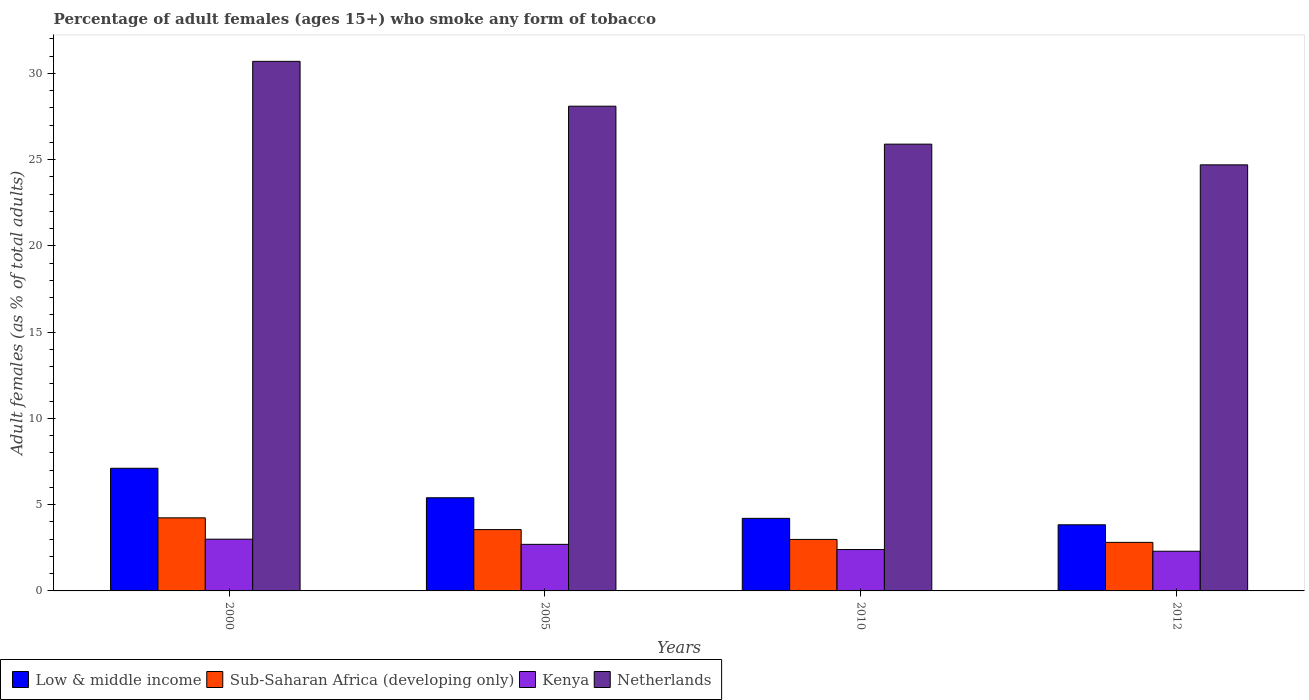How many different coloured bars are there?
Provide a succinct answer. 4. How many bars are there on the 3rd tick from the left?
Ensure brevity in your answer.  4. How many bars are there on the 3rd tick from the right?
Your answer should be compact. 4. What is the label of the 1st group of bars from the left?
Your answer should be very brief. 2000. Across all years, what is the minimum percentage of adult females who smoke in Netherlands?
Provide a succinct answer. 24.7. In which year was the percentage of adult females who smoke in Sub-Saharan Africa (developing only) maximum?
Offer a terse response. 2000. What is the total percentage of adult females who smoke in Kenya in the graph?
Your response must be concise. 10.4. What is the difference between the percentage of adult females who smoke in Sub-Saharan Africa (developing only) in 2000 and that in 2010?
Keep it short and to the point. 1.25. What is the difference between the percentage of adult females who smoke in Kenya in 2000 and the percentage of adult females who smoke in Netherlands in 2010?
Ensure brevity in your answer.  -22.9. What is the average percentage of adult females who smoke in Sub-Saharan Africa (developing only) per year?
Offer a terse response. 3.4. In the year 2000, what is the difference between the percentage of adult females who smoke in Kenya and percentage of adult females who smoke in Sub-Saharan Africa (developing only)?
Make the answer very short. -1.24. In how many years, is the percentage of adult females who smoke in Netherlands greater than 5 %?
Offer a very short reply. 4. What is the ratio of the percentage of adult females who smoke in Kenya in 2000 to that in 2010?
Make the answer very short. 1.25. What is the difference between the highest and the second highest percentage of adult females who smoke in Sub-Saharan Africa (developing only)?
Offer a terse response. 0.68. What is the difference between the highest and the lowest percentage of adult females who smoke in Sub-Saharan Africa (developing only)?
Your answer should be very brief. 1.42. In how many years, is the percentage of adult females who smoke in Low & middle income greater than the average percentage of adult females who smoke in Low & middle income taken over all years?
Offer a very short reply. 2. Are all the bars in the graph horizontal?
Ensure brevity in your answer.  No. Does the graph contain grids?
Provide a succinct answer. No. Where does the legend appear in the graph?
Give a very brief answer. Bottom left. How many legend labels are there?
Provide a short and direct response. 4. What is the title of the graph?
Make the answer very short. Percentage of adult females (ages 15+) who smoke any form of tobacco. Does "Latin America(developing only)" appear as one of the legend labels in the graph?
Your answer should be compact. No. What is the label or title of the Y-axis?
Keep it short and to the point. Adult females (as % of total adults). What is the Adult females (as % of total adults) in Low & middle income in 2000?
Offer a very short reply. 7.11. What is the Adult females (as % of total adults) in Sub-Saharan Africa (developing only) in 2000?
Your answer should be compact. 4.24. What is the Adult females (as % of total adults) in Netherlands in 2000?
Offer a terse response. 30.7. What is the Adult females (as % of total adults) in Low & middle income in 2005?
Ensure brevity in your answer.  5.4. What is the Adult females (as % of total adults) of Sub-Saharan Africa (developing only) in 2005?
Give a very brief answer. 3.55. What is the Adult females (as % of total adults) of Netherlands in 2005?
Your answer should be compact. 28.1. What is the Adult females (as % of total adults) of Low & middle income in 2010?
Offer a terse response. 4.21. What is the Adult females (as % of total adults) of Sub-Saharan Africa (developing only) in 2010?
Offer a very short reply. 2.99. What is the Adult females (as % of total adults) of Kenya in 2010?
Provide a short and direct response. 2.4. What is the Adult females (as % of total adults) in Netherlands in 2010?
Offer a very short reply. 25.9. What is the Adult females (as % of total adults) in Low & middle income in 2012?
Your response must be concise. 3.83. What is the Adult females (as % of total adults) in Sub-Saharan Africa (developing only) in 2012?
Ensure brevity in your answer.  2.81. What is the Adult females (as % of total adults) of Kenya in 2012?
Your response must be concise. 2.3. What is the Adult females (as % of total adults) of Netherlands in 2012?
Make the answer very short. 24.7. Across all years, what is the maximum Adult females (as % of total adults) of Low & middle income?
Offer a terse response. 7.11. Across all years, what is the maximum Adult females (as % of total adults) in Sub-Saharan Africa (developing only)?
Keep it short and to the point. 4.24. Across all years, what is the maximum Adult females (as % of total adults) in Kenya?
Your response must be concise. 3. Across all years, what is the maximum Adult females (as % of total adults) in Netherlands?
Your response must be concise. 30.7. Across all years, what is the minimum Adult females (as % of total adults) in Low & middle income?
Provide a succinct answer. 3.83. Across all years, what is the minimum Adult females (as % of total adults) of Sub-Saharan Africa (developing only)?
Keep it short and to the point. 2.81. Across all years, what is the minimum Adult females (as % of total adults) of Netherlands?
Offer a very short reply. 24.7. What is the total Adult females (as % of total adults) of Low & middle income in the graph?
Provide a short and direct response. 20.55. What is the total Adult females (as % of total adults) in Sub-Saharan Africa (developing only) in the graph?
Your answer should be very brief. 13.59. What is the total Adult females (as % of total adults) in Netherlands in the graph?
Make the answer very short. 109.4. What is the difference between the Adult females (as % of total adults) in Low & middle income in 2000 and that in 2005?
Your answer should be very brief. 1.71. What is the difference between the Adult females (as % of total adults) in Sub-Saharan Africa (developing only) in 2000 and that in 2005?
Your answer should be compact. 0.68. What is the difference between the Adult females (as % of total adults) of Low & middle income in 2000 and that in 2010?
Make the answer very short. 2.9. What is the difference between the Adult females (as % of total adults) of Sub-Saharan Africa (developing only) in 2000 and that in 2010?
Keep it short and to the point. 1.25. What is the difference between the Adult females (as % of total adults) of Kenya in 2000 and that in 2010?
Offer a terse response. 0.6. What is the difference between the Adult females (as % of total adults) of Netherlands in 2000 and that in 2010?
Offer a very short reply. 4.8. What is the difference between the Adult females (as % of total adults) in Low & middle income in 2000 and that in 2012?
Keep it short and to the point. 3.28. What is the difference between the Adult females (as % of total adults) of Sub-Saharan Africa (developing only) in 2000 and that in 2012?
Offer a terse response. 1.42. What is the difference between the Adult females (as % of total adults) in Low & middle income in 2005 and that in 2010?
Offer a terse response. 1.19. What is the difference between the Adult females (as % of total adults) of Sub-Saharan Africa (developing only) in 2005 and that in 2010?
Offer a very short reply. 0.57. What is the difference between the Adult females (as % of total adults) of Netherlands in 2005 and that in 2010?
Offer a terse response. 2.2. What is the difference between the Adult females (as % of total adults) in Low & middle income in 2005 and that in 2012?
Your answer should be very brief. 1.57. What is the difference between the Adult females (as % of total adults) in Sub-Saharan Africa (developing only) in 2005 and that in 2012?
Make the answer very short. 0.74. What is the difference between the Adult females (as % of total adults) of Netherlands in 2005 and that in 2012?
Your answer should be compact. 3.4. What is the difference between the Adult females (as % of total adults) of Low & middle income in 2010 and that in 2012?
Offer a very short reply. 0.37. What is the difference between the Adult females (as % of total adults) of Sub-Saharan Africa (developing only) in 2010 and that in 2012?
Ensure brevity in your answer.  0.17. What is the difference between the Adult females (as % of total adults) of Kenya in 2010 and that in 2012?
Give a very brief answer. 0.1. What is the difference between the Adult females (as % of total adults) of Netherlands in 2010 and that in 2012?
Offer a very short reply. 1.2. What is the difference between the Adult females (as % of total adults) of Low & middle income in 2000 and the Adult females (as % of total adults) of Sub-Saharan Africa (developing only) in 2005?
Your answer should be very brief. 3.56. What is the difference between the Adult females (as % of total adults) of Low & middle income in 2000 and the Adult females (as % of total adults) of Kenya in 2005?
Your answer should be very brief. 4.41. What is the difference between the Adult females (as % of total adults) of Low & middle income in 2000 and the Adult females (as % of total adults) of Netherlands in 2005?
Offer a very short reply. -20.99. What is the difference between the Adult females (as % of total adults) of Sub-Saharan Africa (developing only) in 2000 and the Adult females (as % of total adults) of Kenya in 2005?
Your answer should be very brief. 1.54. What is the difference between the Adult females (as % of total adults) of Sub-Saharan Africa (developing only) in 2000 and the Adult females (as % of total adults) of Netherlands in 2005?
Offer a very short reply. -23.86. What is the difference between the Adult females (as % of total adults) of Kenya in 2000 and the Adult females (as % of total adults) of Netherlands in 2005?
Your answer should be very brief. -25.1. What is the difference between the Adult females (as % of total adults) in Low & middle income in 2000 and the Adult females (as % of total adults) in Sub-Saharan Africa (developing only) in 2010?
Make the answer very short. 4.13. What is the difference between the Adult females (as % of total adults) in Low & middle income in 2000 and the Adult females (as % of total adults) in Kenya in 2010?
Offer a terse response. 4.71. What is the difference between the Adult females (as % of total adults) in Low & middle income in 2000 and the Adult females (as % of total adults) in Netherlands in 2010?
Your response must be concise. -18.79. What is the difference between the Adult females (as % of total adults) of Sub-Saharan Africa (developing only) in 2000 and the Adult females (as % of total adults) of Kenya in 2010?
Offer a terse response. 1.84. What is the difference between the Adult females (as % of total adults) in Sub-Saharan Africa (developing only) in 2000 and the Adult females (as % of total adults) in Netherlands in 2010?
Your answer should be very brief. -21.66. What is the difference between the Adult females (as % of total adults) of Kenya in 2000 and the Adult females (as % of total adults) of Netherlands in 2010?
Make the answer very short. -22.9. What is the difference between the Adult females (as % of total adults) in Low & middle income in 2000 and the Adult females (as % of total adults) in Sub-Saharan Africa (developing only) in 2012?
Offer a very short reply. 4.3. What is the difference between the Adult females (as % of total adults) of Low & middle income in 2000 and the Adult females (as % of total adults) of Kenya in 2012?
Offer a very short reply. 4.81. What is the difference between the Adult females (as % of total adults) of Low & middle income in 2000 and the Adult females (as % of total adults) of Netherlands in 2012?
Your response must be concise. -17.59. What is the difference between the Adult females (as % of total adults) of Sub-Saharan Africa (developing only) in 2000 and the Adult females (as % of total adults) of Kenya in 2012?
Make the answer very short. 1.94. What is the difference between the Adult females (as % of total adults) in Sub-Saharan Africa (developing only) in 2000 and the Adult females (as % of total adults) in Netherlands in 2012?
Give a very brief answer. -20.46. What is the difference between the Adult females (as % of total adults) in Kenya in 2000 and the Adult females (as % of total adults) in Netherlands in 2012?
Offer a terse response. -21.7. What is the difference between the Adult females (as % of total adults) of Low & middle income in 2005 and the Adult females (as % of total adults) of Sub-Saharan Africa (developing only) in 2010?
Provide a succinct answer. 2.42. What is the difference between the Adult females (as % of total adults) in Low & middle income in 2005 and the Adult females (as % of total adults) in Kenya in 2010?
Offer a very short reply. 3. What is the difference between the Adult females (as % of total adults) in Low & middle income in 2005 and the Adult females (as % of total adults) in Netherlands in 2010?
Your answer should be compact. -20.5. What is the difference between the Adult females (as % of total adults) in Sub-Saharan Africa (developing only) in 2005 and the Adult females (as % of total adults) in Kenya in 2010?
Ensure brevity in your answer.  1.15. What is the difference between the Adult females (as % of total adults) in Sub-Saharan Africa (developing only) in 2005 and the Adult females (as % of total adults) in Netherlands in 2010?
Offer a very short reply. -22.35. What is the difference between the Adult females (as % of total adults) of Kenya in 2005 and the Adult females (as % of total adults) of Netherlands in 2010?
Your answer should be very brief. -23.2. What is the difference between the Adult females (as % of total adults) of Low & middle income in 2005 and the Adult females (as % of total adults) of Sub-Saharan Africa (developing only) in 2012?
Offer a very short reply. 2.59. What is the difference between the Adult females (as % of total adults) of Low & middle income in 2005 and the Adult females (as % of total adults) of Kenya in 2012?
Give a very brief answer. 3.1. What is the difference between the Adult females (as % of total adults) in Low & middle income in 2005 and the Adult females (as % of total adults) in Netherlands in 2012?
Ensure brevity in your answer.  -19.3. What is the difference between the Adult females (as % of total adults) of Sub-Saharan Africa (developing only) in 2005 and the Adult females (as % of total adults) of Kenya in 2012?
Make the answer very short. 1.25. What is the difference between the Adult females (as % of total adults) in Sub-Saharan Africa (developing only) in 2005 and the Adult females (as % of total adults) in Netherlands in 2012?
Keep it short and to the point. -21.15. What is the difference between the Adult females (as % of total adults) of Kenya in 2005 and the Adult females (as % of total adults) of Netherlands in 2012?
Provide a short and direct response. -22. What is the difference between the Adult females (as % of total adults) of Low & middle income in 2010 and the Adult females (as % of total adults) of Sub-Saharan Africa (developing only) in 2012?
Keep it short and to the point. 1.39. What is the difference between the Adult females (as % of total adults) in Low & middle income in 2010 and the Adult females (as % of total adults) in Kenya in 2012?
Offer a very short reply. 1.91. What is the difference between the Adult females (as % of total adults) in Low & middle income in 2010 and the Adult females (as % of total adults) in Netherlands in 2012?
Offer a very short reply. -20.49. What is the difference between the Adult females (as % of total adults) in Sub-Saharan Africa (developing only) in 2010 and the Adult females (as % of total adults) in Kenya in 2012?
Offer a very short reply. 0.69. What is the difference between the Adult females (as % of total adults) in Sub-Saharan Africa (developing only) in 2010 and the Adult females (as % of total adults) in Netherlands in 2012?
Provide a succinct answer. -21.71. What is the difference between the Adult females (as % of total adults) in Kenya in 2010 and the Adult females (as % of total adults) in Netherlands in 2012?
Offer a very short reply. -22.3. What is the average Adult females (as % of total adults) in Low & middle income per year?
Your answer should be compact. 5.14. What is the average Adult females (as % of total adults) in Sub-Saharan Africa (developing only) per year?
Provide a short and direct response. 3.4. What is the average Adult females (as % of total adults) in Kenya per year?
Keep it short and to the point. 2.6. What is the average Adult females (as % of total adults) in Netherlands per year?
Keep it short and to the point. 27.35. In the year 2000, what is the difference between the Adult females (as % of total adults) of Low & middle income and Adult females (as % of total adults) of Sub-Saharan Africa (developing only)?
Keep it short and to the point. 2.87. In the year 2000, what is the difference between the Adult females (as % of total adults) of Low & middle income and Adult females (as % of total adults) of Kenya?
Ensure brevity in your answer.  4.11. In the year 2000, what is the difference between the Adult females (as % of total adults) of Low & middle income and Adult females (as % of total adults) of Netherlands?
Your answer should be compact. -23.59. In the year 2000, what is the difference between the Adult females (as % of total adults) of Sub-Saharan Africa (developing only) and Adult females (as % of total adults) of Kenya?
Make the answer very short. 1.24. In the year 2000, what is the difference between the Adult females (as % of total adults) in Sub-Saharan Africa (developing only) and Adult females (as % of total adults) in Netherlands?
Make the answer very short. -26.46. In the year 2000, what is the difference between the Adult females (as % of total adults) of Kenya and Adult females (as % of total adults) of Netherlands?
Provide a succinct answer. -27.7. In the year 2005, what is the difference between the Adult females (as % of total adults) of Low & middle income and Adult females (as % of total adults) of Sub-Saharan Africa (developing only)?
Offer a terse response. 1.85. In the year 2005, what is the difference between the Adult females (as % of total adults) of Low & middle income and Adult females (as % of total adults) of Kenya?
Ensure brevity in your answer.  2.7. In the year 2005, what is the difference between the Adult females (as % of total adults) in Low & middle income and Adult females (as % of total adults) in Netherlands?
Your answer should be compact. -22.7. In the year 2005, what is the difference between the Adult females (as % of total adults) of Sub-Saharan Africa (developing only) and Adult females (as % of total adults) of Kenya?
Offer a very short reply. 0.85. In the year 2005, what is the difference between the Adult females (as % of total adults) of Sub-Saharan Africa (developing only) and Adult females (as % of total adults) of Netherlands?
Provide a succinct answer. -24.55. In the year 2005, what is the difference between the Adult females (as % of total adults) of Kenya and Adult females (as % of total adults) of Netherlands?
Provide a succinct answer. -25.4. In the year 2010, what is the difference between the Adult females (as % of total adults) in Low & middle income and Adult females (as % of total adults) in Sub-Saharan Africa (developing only)?
Offer a terse response. 1.22. In the year 2010, what is the difference between the Adult females (as % of total adults) of Low & middle income and Adult females (as % of total adults) of Kenya?
Give a very brief answer. 1.81. In the year 2010, what is the difference between the Adult females (as % of total adults) in Low & middle income and Adult females (as % of total adults) in Netherlands?
Provide a succinct answer. -21.69. In the year 2010, what is the difference between the Adult females (as % of total adults) in Sub-Saharan Africa (developing only) and Adult females (as % of total adults) in Kenya?
Your answer should be compact. 0.59. In the year 2010, what is the difference between the Adult females (as % of total adults) of Sub-Saharan Africa (developing only) and Adult females (as % of total adults) of Netherlands?
Your response must be concise. -22.91. In the year 2010, what is the difference between the Adult females (as % of total adults) in Kenya and Adult females (as % of total adults) in Netherlands?
Offer a terse response. -23.5. In the year 2012, what is the difference between the Adult females (as % of total adults) of Low & middle income and Adult females (as % of total adults) of Sub-Saharan Africa (developing only)?
Ensure brevity in your answer.  1.02. In the year 2012, what is the difference between the Adult females (as % of total adults) in Low & middle income and Adult females (as % of total adults) in Kenya?
Offer a very short reply. 1.53. In the year 2012, what is the difference between the Adult females (as % of total adults) of Low & middle income and Adult females (as % of total adults) of Netherlands?
Your answer should be very brief. -20.87. In the year 2012, what is the difference between the Adult females (as % of total adults) of Sub-Saharan Africa (developing only) and Adult females (as % of total adults) of Kenya?
Your answer should be very brief. 0.51. In the year 2012, what is the difference between the Adult females (as % of total adults) of Sub-Saharan Africa (developing only) and Adult females (as % of total adults) of Netherlands?
Your answer should be very brief. -21.89. In the year 2012, what is the difference between the Adult females (as % of total adults) of Kenya and Adult females (as % of total adults) of Netherlands?
Ensure brevity in your answer.  -22.4. What is the ratio of the Adult females (as % of total adults) in Low & middle income in 2000 to that in 2005?
Give a very brief answer. 1.32. What is the ratio of the Adult females (as % of total adults) in Sub-Saharan Africa (developing only) in 2000 to that in 2005?
Your answer should be very brief. 1.19. What is the ratio of the Adult females (as % of total adults) in Netherlands in 2000 to that in 2005?
Offer a terse response. 1.09. What is the ratio of the Adult females (as % of total adults) of Low & middle income in 2000 to that in 2010?
Ensure brevity in your answer.  1.69. What is the ratio of the Adult females (as % of total adults) in Sub-Saharan Africa (developing only) in 2000 to that in 2010?
Your response must be concise. 1.42. What is the ratio of the Adult females (as % of total adults) of Kenya in 2000 to that in 2010?
Your response must be concise. 1.25. What is the ratio of the Adult females (as % of total adults) in Netherlands in 2000 to that in 2010?
Make the answer very short. 1.19. What is the ratio of the Adult females (as % of total adults) of Low & middle income in 2000 to that in 2012?
Your answer should be very brief. 1.85. What is the ratio of the Adult females (as % of total adults) in Sub-Saharan Africa (developing only) in 2000 to that in 2012?
Keep it short and to the point. 1.51. What is the ratio of the Adult females (as % of total adults) of Kenya in 2000 to that in 2012?
Offer a terse response. 1.3. What is the ratio of the Adult females (as % of total adults) of Netherlands in 2000 to that in 2012?
Offer a terse response. 1.24. What is the ratio of the Adult females (as % of total adults) in Low & middle income in 2005 to that in 2010?
Provide a short and direct response. 1.28. What is the ratio of the Adult females (as % of total adults) of Sub-Saharan Africa (developing only) in 2005 to that in 2010?
Give a very brief answer. 1.19. What is the ratio of the Adult females (as % of total adults) in Kenya in 2005 to that in 2010?
Ensure brevity in your answer.  1.12. What is the ratio of the Adult females (as % of total adults) in Netherlands in 2005 to that in 2010?
Ensure brevity in your answer.  1.08. What is the ratio of the Adult females (as % of total adults) in Low & middle income in 2005 to that in 2012?
Ensure brevity in your answer.  1.41. What is the ratio of the Adult females (as % of total adults) of Sub-Saharan Africa (developing only) in 2005 to that in 2012?
Offer a terse response. 1.26. What is the ratio of the Adult females (as % of total adults) in Kenya in 2005 to that in 2012?
Provide a succinct answer. 1.17. What is the ratio of the Adult females (as % of total adults) of Netherlands in 2005 to that in 2012?
Your response must be concise. 1.14. What is the ratio of the Adult females (as % of total adults) of Low & middle income in 2010 to that in 2012?
Ensure brevity in your answer.  1.1. What is the ratio of the Adult females (as % of total adults) of Sub-Saharan Africa (developing only) in 2010 to that in 2012?
Provide a short and direct response. 1.06. What is the ratio of the Adult females (as % of total adults) in Kenya in 2010 to that in 2012?
Offer a very short reply. 1.04. What is the ratio of the Adult females (as % of total adults) of Netherlands in 2010 to that in 2012?
Your response must be concise. 1.05. What is the difference between the highest and the second highest Adult females (as % of total adults) of Low & middle income?
Your answer should be very brief. 1.71. What is the difference between the highest and the second highest Adult females (as % of total adults) in Sub-Saharan Africa (developing only)?
Make the answer very short. 0.68. What is the difference between the highest and the second highest Adult females (as % of total adults) in Kenya?
Your response must be concise. 0.3. What is the difference between the highest and the lowest Adult females (as % of total adults) in Low & middle income?
Offer a terse response. 3.28. What is the difference between the highest and the lowest Adult females (as % of total adults) in Sub-Saharan Africa (developing only)?
Your answer should be very brief. 1.42. What is the difference between the highest and the lowest Adult females (as % of total adults) in Kenya?
Your answer should be compact. 0.7. What is the difference between the highest and the lowest Adult females (as % of total adults) of Netherlands?
Provide a short and direct response. 6. 